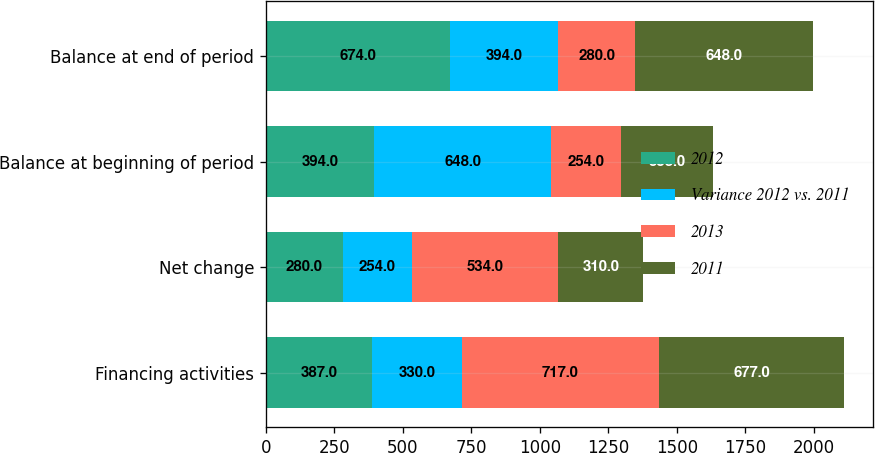Convert chart. <chart><loc_0><loc_0><loc_500><loc_500><stacked_bar_chart><ecel><fcel>Financing activities<fcel>Net change<fcel>Balance at beginning of period<fcel>Balance at end of period<nl><fcel>2012<fcel>387<fcel>280<fcel>394<fcel>674<nl><fcel>Variance 2012 vs. 2011<fcel>330<fcel>254<fcel>648<fcel>394<nl><fcel>2013<fcel>717<fcel>534<fcel>254<fcel>280<nl><fcel>2011<fcel>677<fcel>310<fcel>338<fcel>648<nl></chart> 